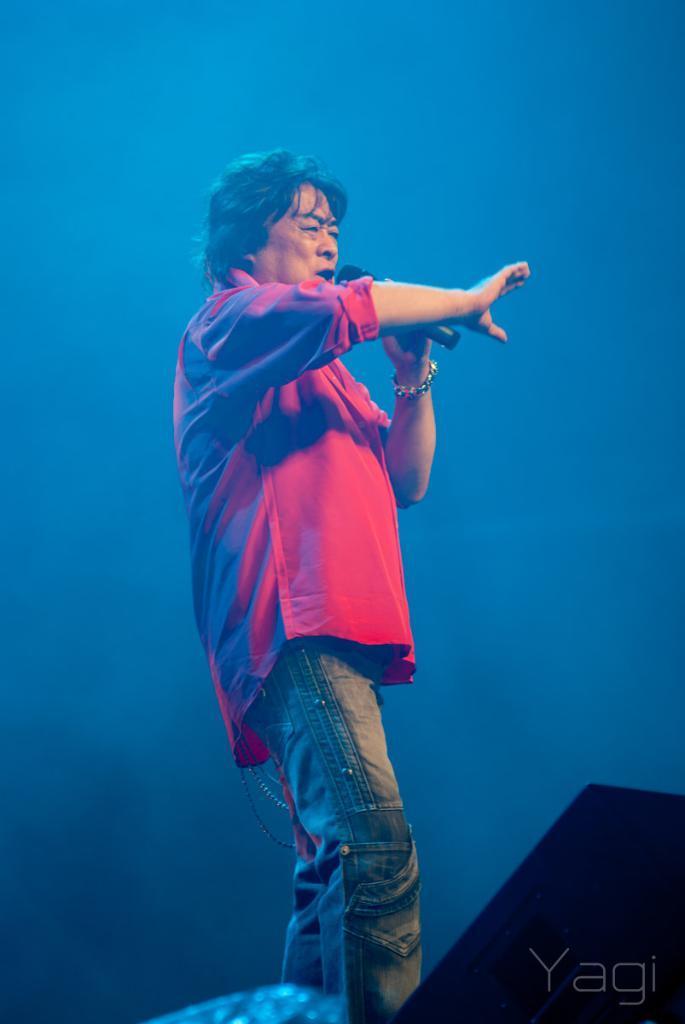Could you give a brief overview of what you see in this image? In this image there is a man wearing a red color shirt and holding mike. There is a blue color background. 